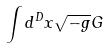<formula> <loc_0><loc_0><loc_500><loc_500>\int d ^ { D } x \sqrt { - g } G</formula> 